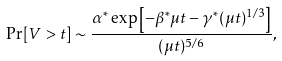<formula> <loc_0><loc_0><loc_500><loc_500>\Pr [ V > t ] \sim \frac { \alpha ^ { * } \exp \left [ - \beta ^ { * } \mu t - \gamma ^ { * } ( \mu t ) ^ { 1 / 3 } \right ] } { ( \mu t ) ^ { 5 / 6 } } ,</formula> 